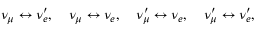<formula> <loc_0><loc_0><loc_500><loc_500>\nu _ { \mu } \leftrightarrow \nu _ { e } ^ { \prime } , \quad \nu _ { \mu } \leftrightarrow \nu _ { e } , \quad \nu _ { \mu } ^ { \prime } \leftrightarrow \nu _ { e } , \quad \nu _ { \mu } ^ { \prime } \leftrightarrow \nu _ { e } ^ { \prime } ,</formula> 